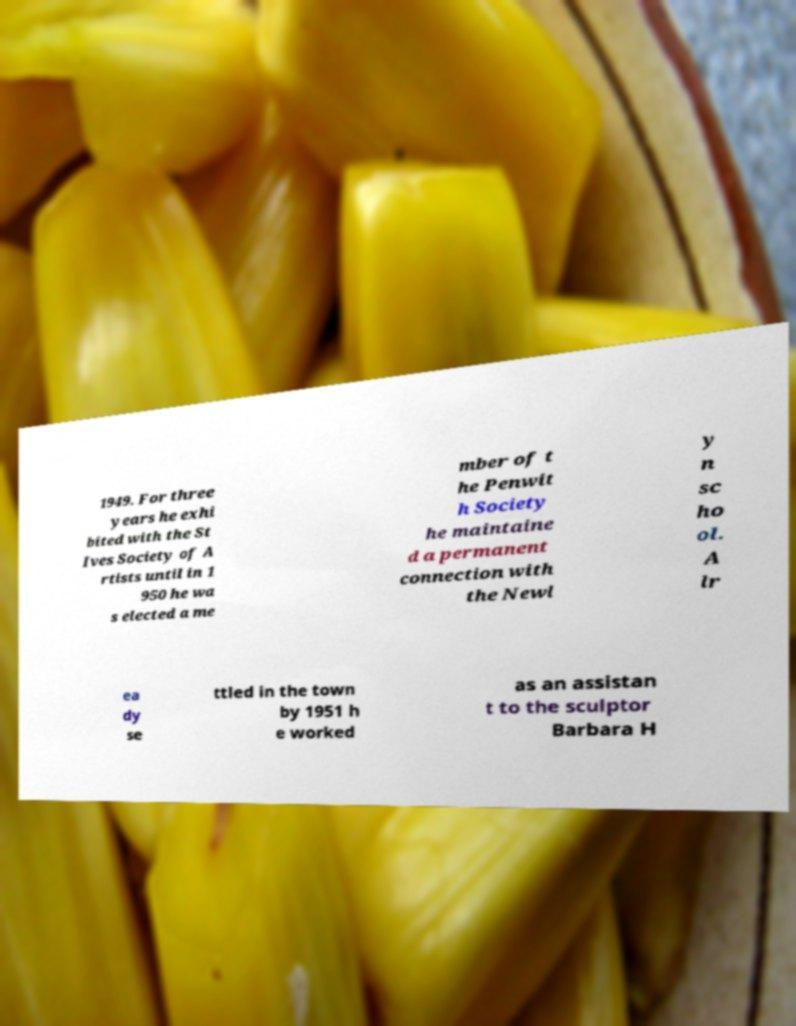For documentation purposes, I need the text within this image transcribed. Could you provide that? 1949. For three years he exhi bited with the St Ives Society of A rtists until in 1 950 he wa s elected a me mber of t he Penwit h Society he maintaine d a permanent connection with the Newl y n sc ho ol. A lr ea dy se ttled in the town by 1951 h e worked as an assistan t to the sculptor Barbara H 